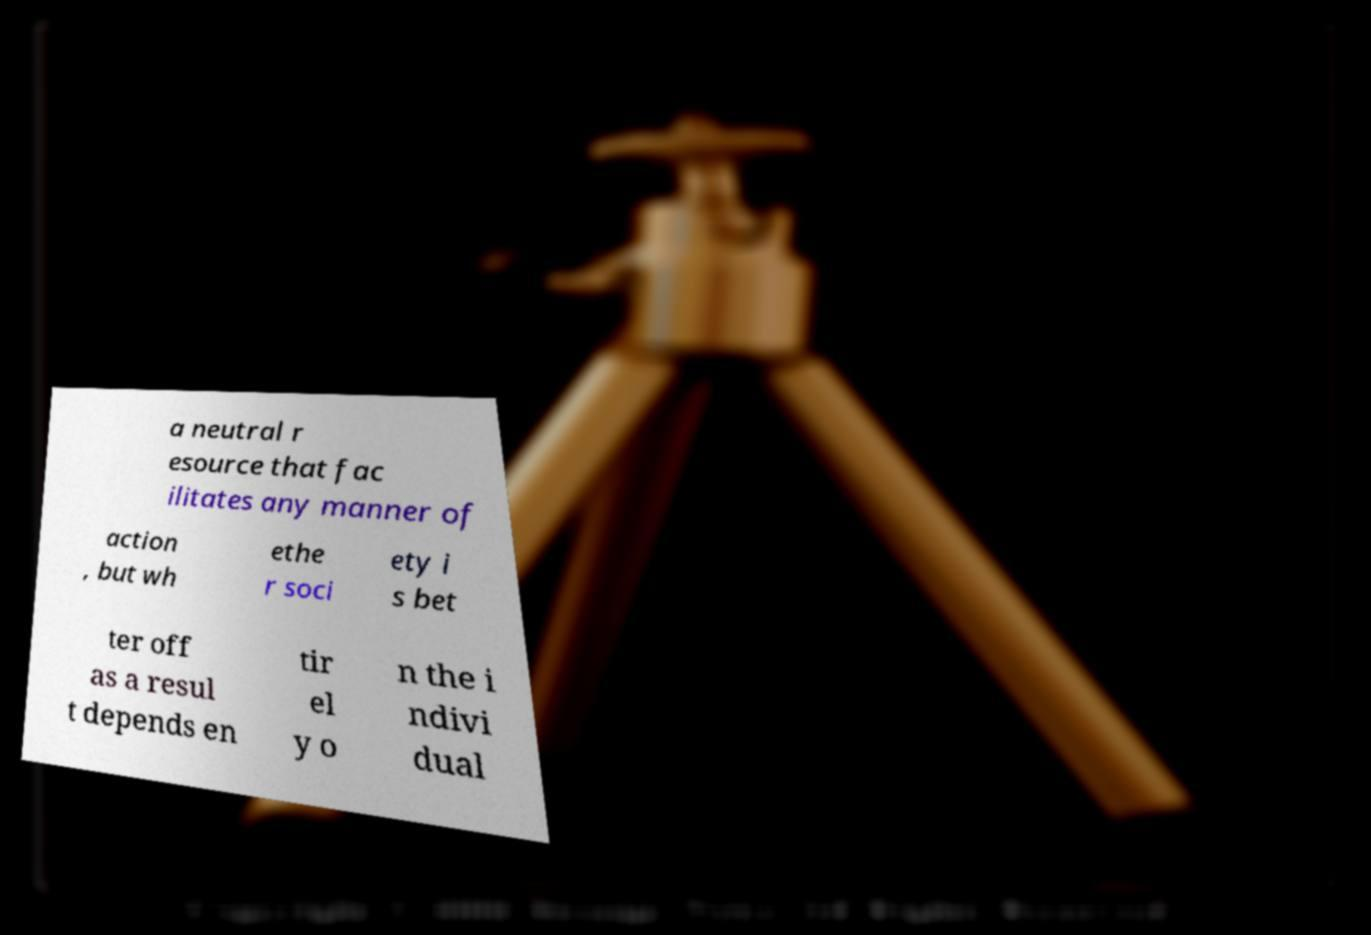What messages or text are displayed in this image? I need them in a readable, typed format. a neutral r esource that fac ilitates any manner of action , but wh ethe r soci ety i s bet ter off as a resul t depends en tir el y o n the i ndivi dual 